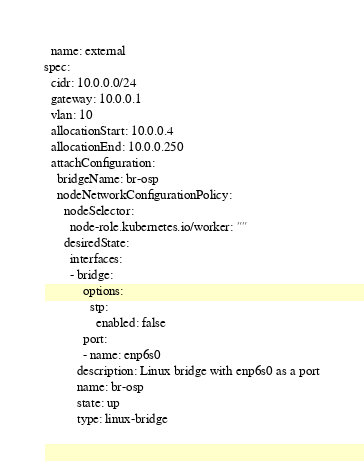Convert code to text. <code><loc_0><loc_0><loc_500><loc_500><_YAML_>  name: external
spec:
  cidr: 10.0.0.0/24
  gateway: 10.0.0.1
  vlan: 10
  allocationStart: 10.0.0.4
  allocationEnd: 10.0.0.250
  attachConfiguration:
    bridgeName: br-osp
    nodeNetworkConfigurationPolicy:
      nodeSelector:
        node-role.kubernetes.io/worker: ""
      desiredState:
        interfaces:
        - bridge:
            options:
              stp:
                enabled: false
            port:
            - name: enp6s0
          description: Linux bridge with enp6s0 as a port
          name: br-osp
          state: up
          type: linux-bridge</code> 